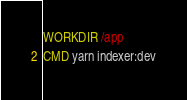Convert code to text. <code><loc_0><loc_0><loc_500><loc_500><_Dockerfile_>WORKDIR /app
CMD yarn indexer:dev</code> 